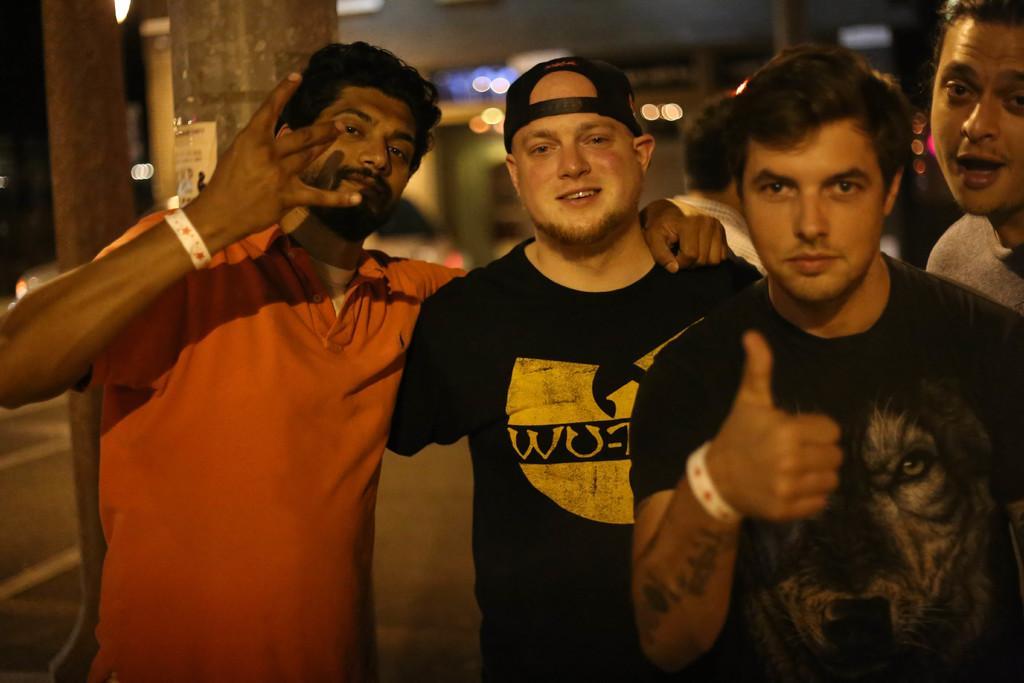How would you summarize this image in a sentence or two? In this image we can see a group of people standing on the ground. On the left side of the image we can see some poles and a vehicle parked on the ground. In the background, we can see some lights. 